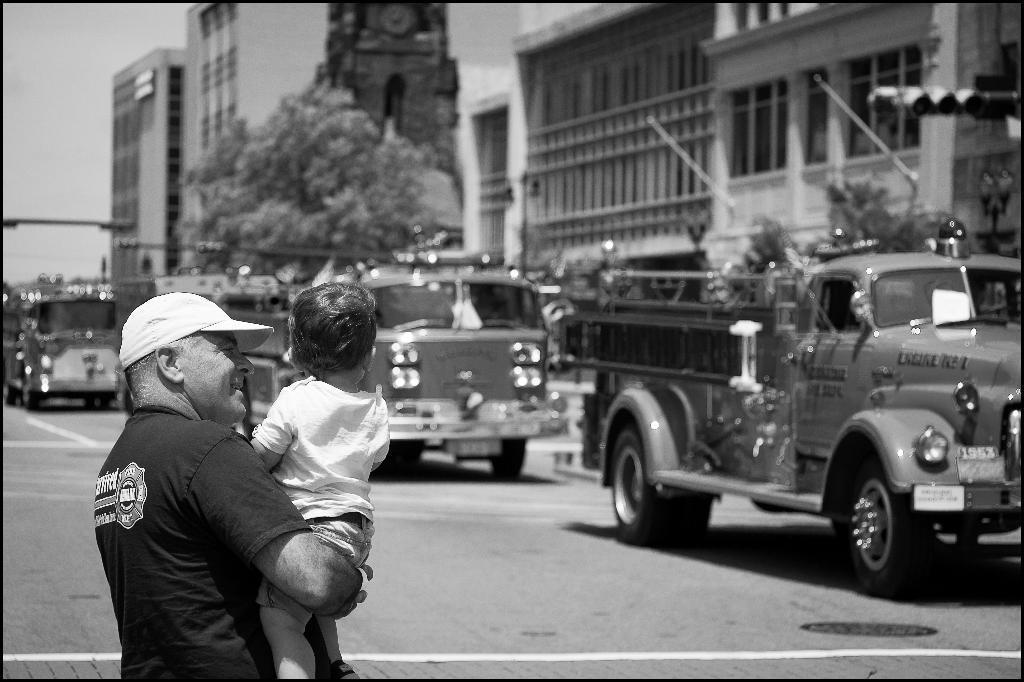How would you summarize this image in a sentence or two? In this image we can see the person standing and holding a kid. And there are vehicles on the road. And there are buildings, tree, light pole, street light and the sky. 